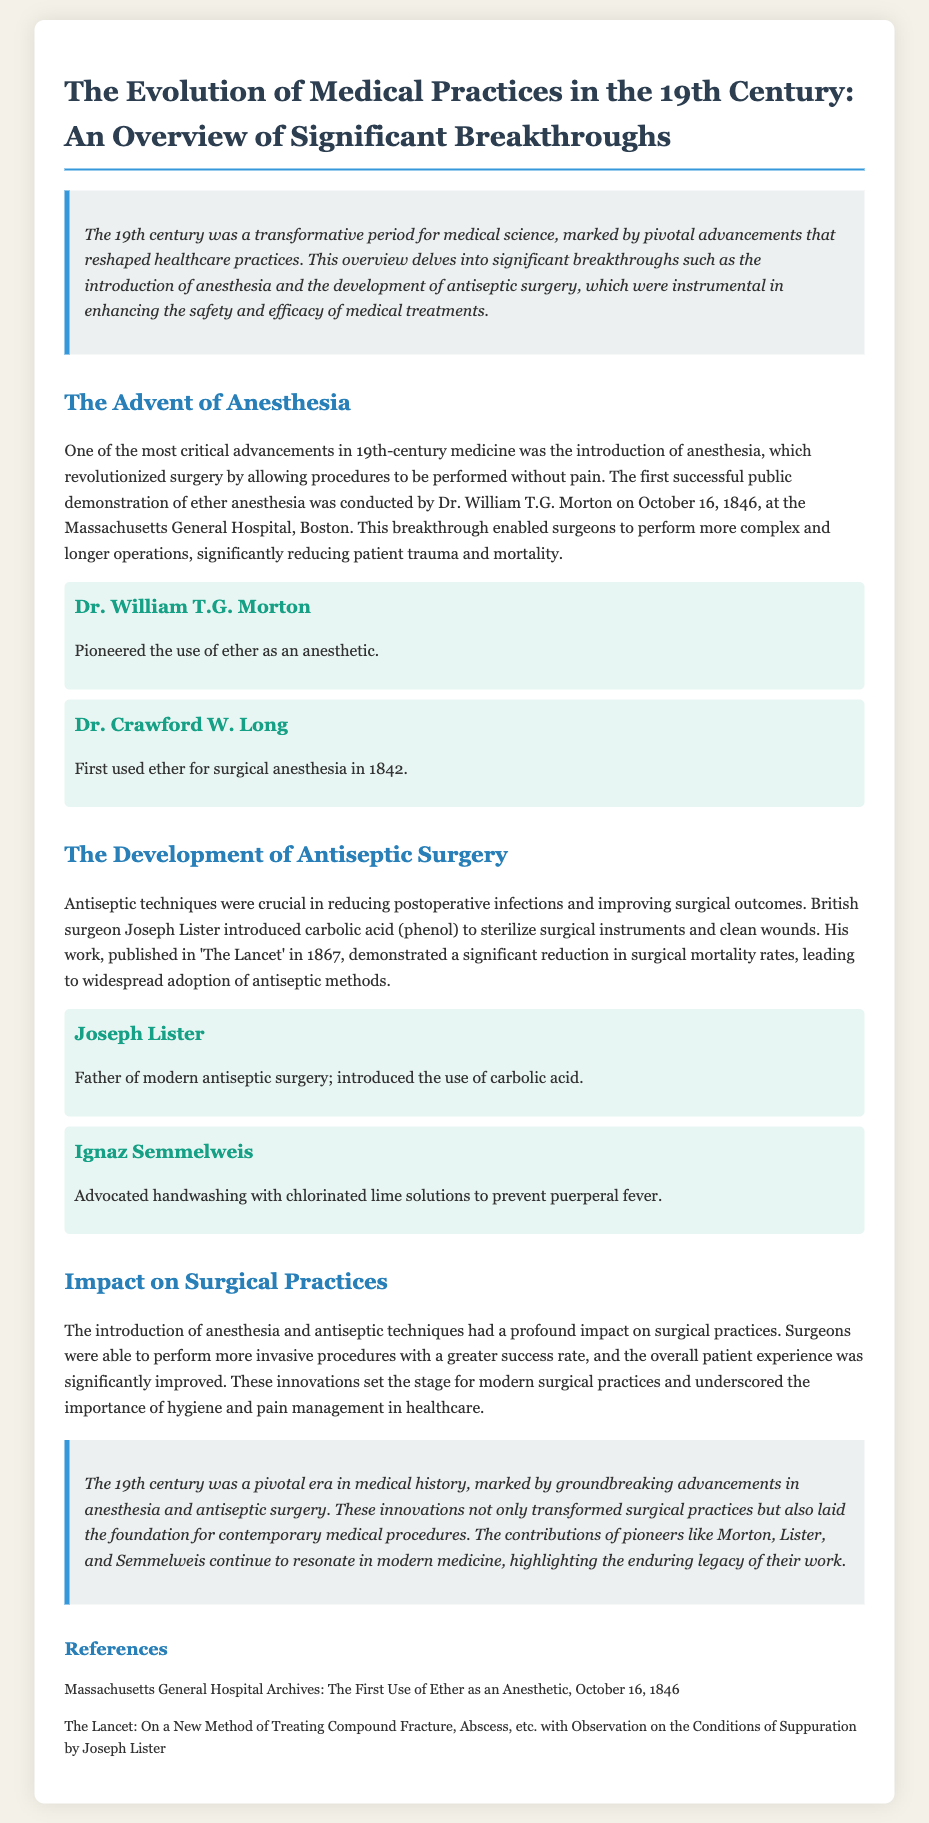What was the date of the first successful public demonstration of ether anesthesia? The document states that the first successful public demonstration of ether anesthesia occurred on October 16, 1846.
Answer: October 16, 1846 Who introduced carbolic acid for antiseptic surgery? According to the document, Joseph Lister is credited with introducing carbolic acid (phenol) to establish antiseptic surgery.
Answer: Joseph Lister What significant reduction did Joseph Lister's work demonstrate? The document highlights that Joseph Lister's work showed a significant reduction in surgical mortality rates with the adoption of antiseptic methods.
Answer: Surgical mortality rates Who is recognized as the father of modern antiseptic surgery? The document attributes the title of the father of modern antiseptic surgery to Joseph Lister for his pioneering work.
Answer: Joseph Lister In what year did Joseph Lister publish his work in 'The Lancet'? The document states that Joseph Lister published his work in 'The Lancet' in 1867.
Answer: 1867 What was the impact of anesthesia on surgical practices? The document explains that the introduction of anesthesia allowed for more complex and longer operations, significantly reducing patient trauma and mortality.
Answer: More complex operations What did Ignaz Semmelweis advocate to prevent puerperal fever? The document mentions that Ignaz Semmelweis advocated handwashing with chlorinated lime solutions to prevent puerperal fever.
Answer: Handwashing What was one of the key advancements in 19th-century medicine highlighted in the document? The document emphasizes that the introduction of anesthesia was one of the critical advancements in 19th-century medicine.
Answer: Anesthesia How did the advancements in the 19th century influence modern surgical practices? The document explains that these innovations set the stage for modern surgical practices by underscoring the importance of hygiene and pain management.
Answer: Set the stage for modern practices 